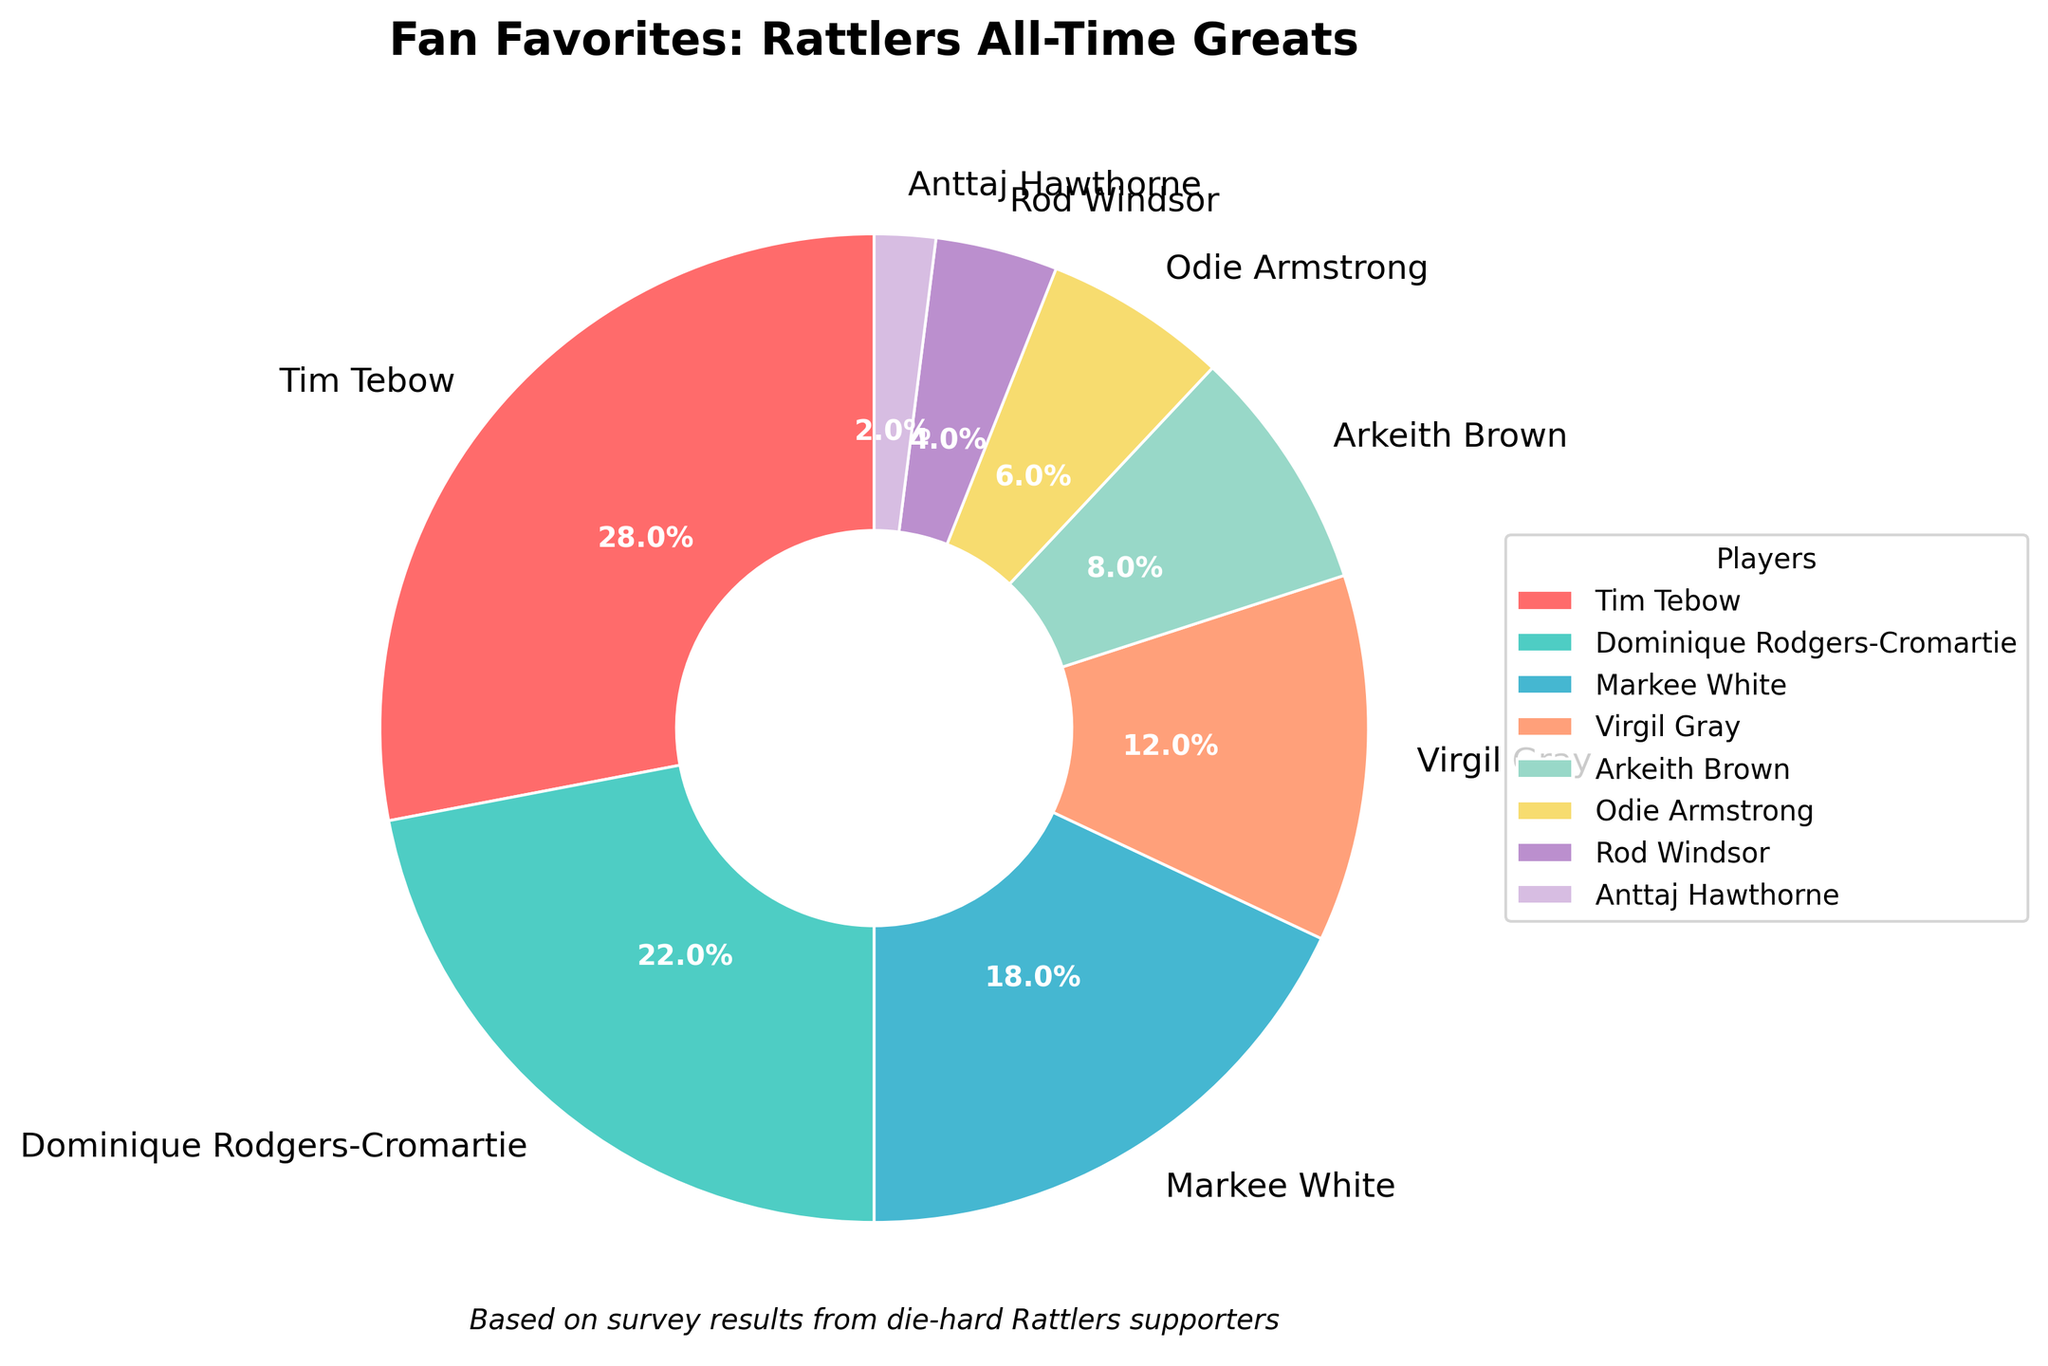Who is the most favorite Rattlers player of all time according to the survey? By looking at the largest wedge in the pie chart, we can see that Tim Tebow has the highest percentage of votes.
Answer: Tim Tebow Which two players have the highest percentage of votes combined? By visually assessing the chart, Tim Tebow (28%) and Dominique Rodgers-Cromartie (22%) have the highest individual percentages. Summing these gives 28% + 22% = 50%.
Answer: Tim Tebow and Dominique Rodgers-Cromartie How does Markee White's popularity compare to Virgil Gray's? Markee White has a 18% share, whereas Virgil Gray has a 12% share. Markee White’s share is larger than Virgil Gray's by 6%.
Answer: Markee White has more votes If you combine the percentages of the three least favorite players, what is their total percentage? The three players with the lowest percentages are Rod Windsor (4%), Anttaj Hawthorne (2%), and Odie Armstrong (6%). Adding these gives 4% + 2% + 6% = 12%.
Answer: 12% What is the combined percentage of the top three players according to the survey? The top three players are Tim Tebow (28%), Dominique Rodgers-Cromartie (22%), and Markee White (18%). Summing these gives 28% + 22% + 18% = 68%.
Answer: 68% What color represents Dominique Rodgers-Cromartie's segment in the pie chart? In the pie chart, Dominique Rodgers-Cromartie's segment is the second largest and it is represented by the color turquoise.
Answer: Turquoise How much greater is Arkeith Brown's percentage compared to Odie Armstrong's? Arkeith Brown has 8% while Odie Armstrong has 6%. The difference between them is 8% - 6% = 2%.
Answer: 2% Which player received the second smallest percentage of votes and what is that percentage? Rod Windsor received the second smallest percentage of votes with 4%, as seen in the pie chart where his segment is one size larger than Anttaj Hawthorne's 2%.
Answer: Rod Windsor with 4% Among the players who received less than 10% of the votes, which one had the highest percentage? Among those with less than 10%, Arkeith Brown has the largest share with 8%, followed by Odie Armstrong (6%) and Rod Windsor (4%).
Answer: Arkeith Brown Who are the middle-ranking players in terms of survey popularity? The middle-ranking players are Markee White (18%) and Virgil Gray (12%), who fall in between the top two and bottom four players.
Answer: Markee White and Virgil Gray 